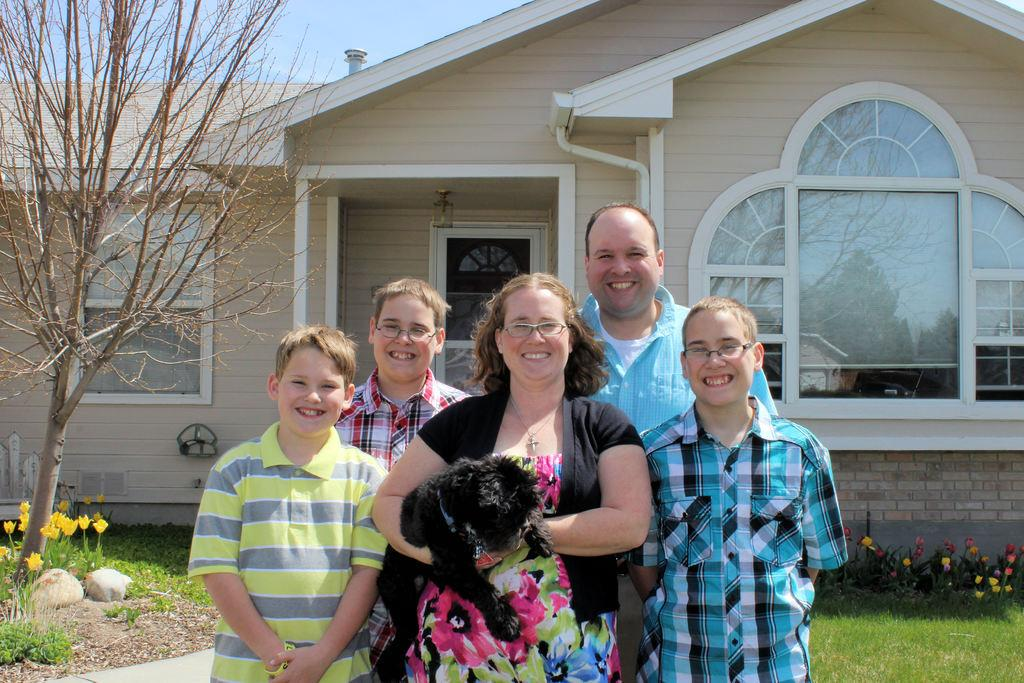How many people are present in the image? There are five people in the image. What other living creature can be seen in the image? There is a dog in the image. How is the dog being held in the image? A woman is holding the dog in her hand. What can be seen in the background of the image? There is a house and a tree in the background of the image. What type of insurance policy is the woman discussing with the dog in the image? There is no indication in the image that the woman is discussing any insurance policy, nor is there any conversation depicted. 